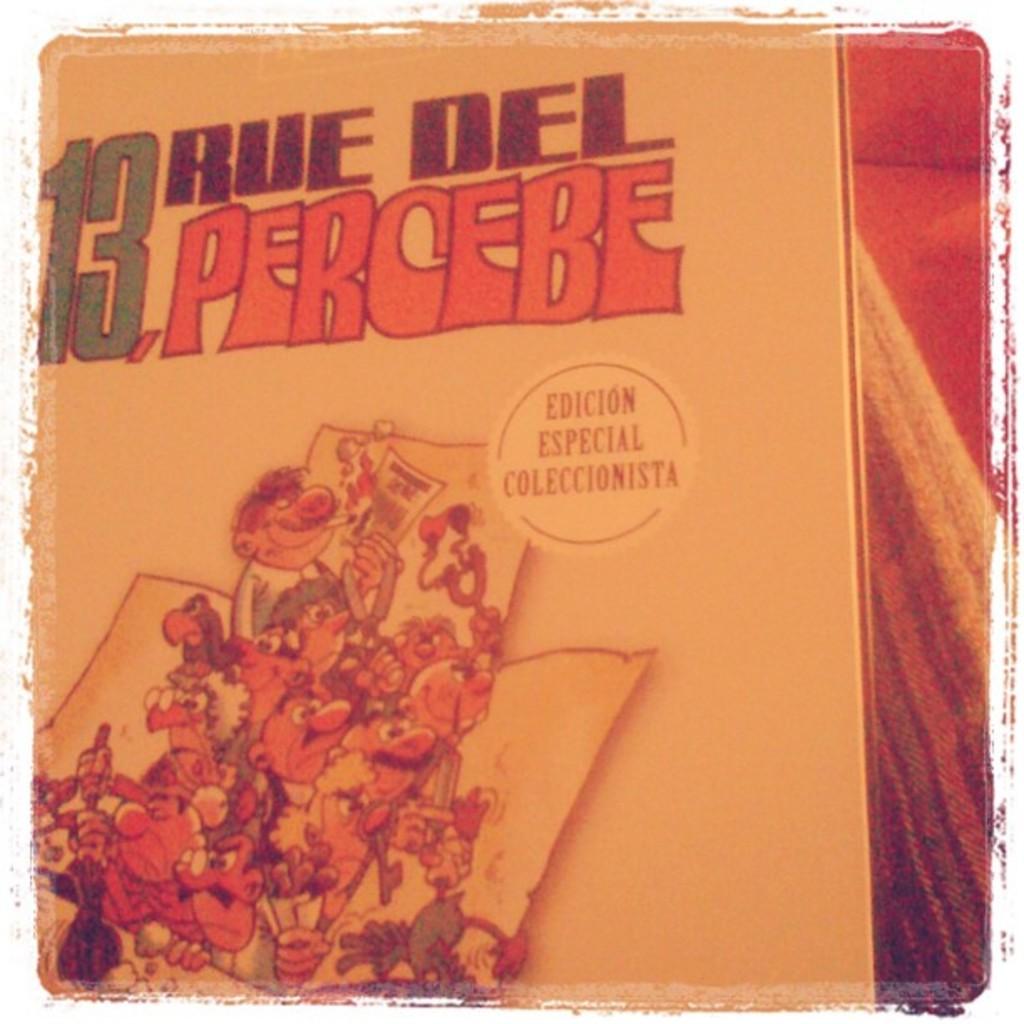What does the white circle say?
Offer a very short reply. Edicion especial coleccionista. 